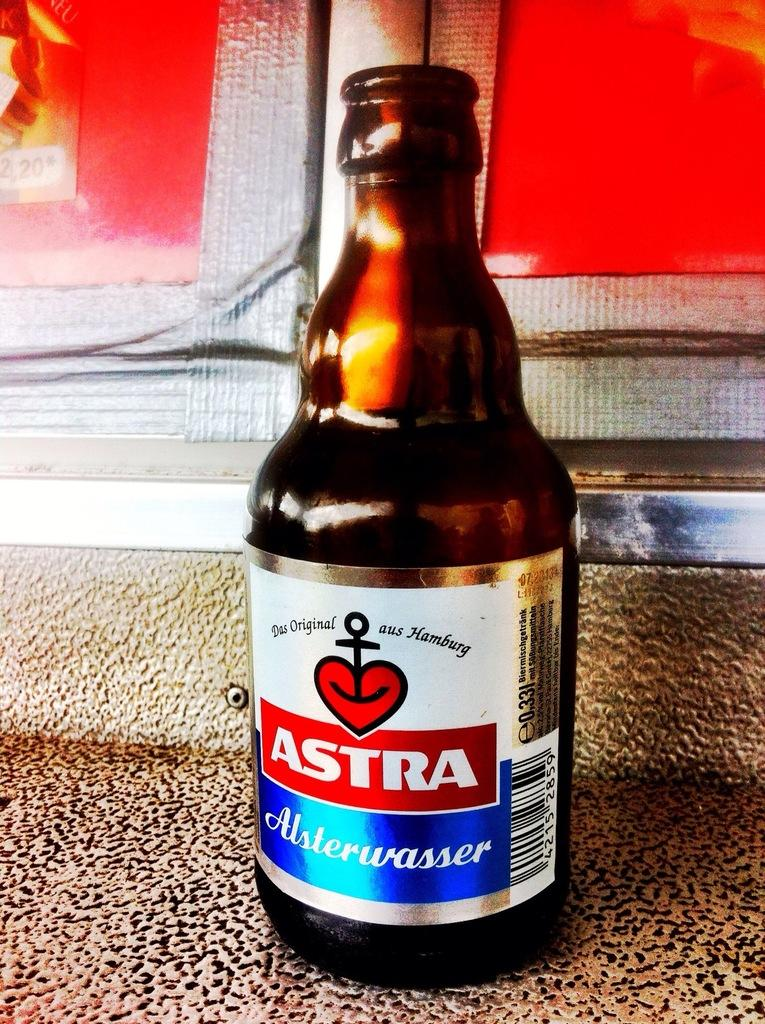<image>
Summarize the visual content of the image. A bottle of Astra Alsterwasser Sits on a grey surface 